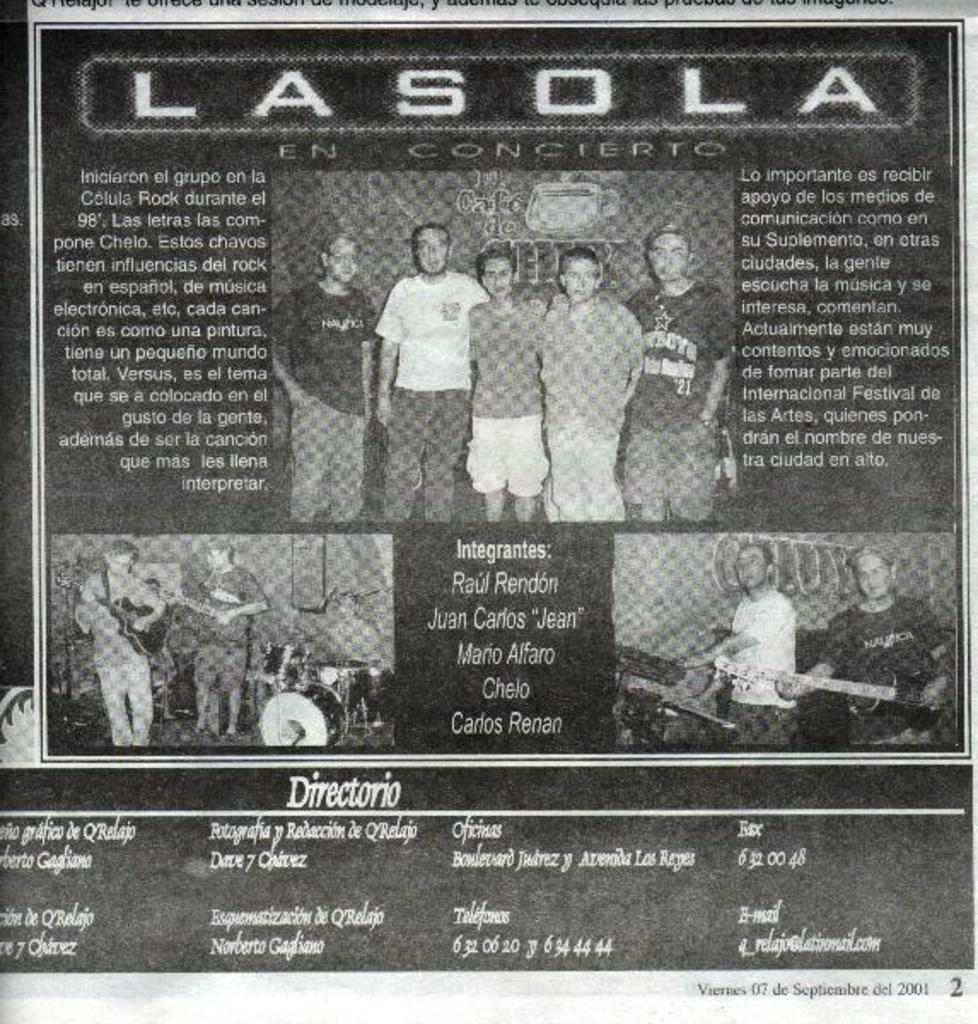How would you summarize this image in a sentence or two? I see this is a black and white image and I see there are many words written and I see pictures of persons and I see few of them are holding musical instruments in their hands and I see the numbers over here. 